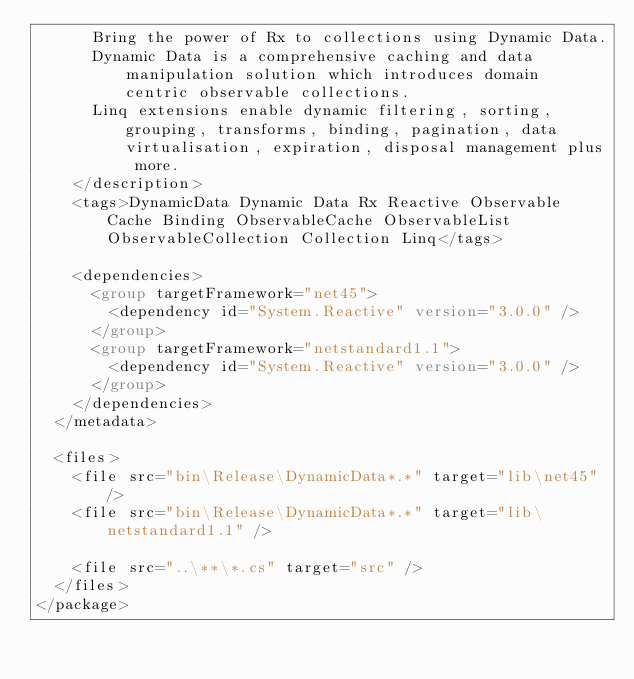<code> <loc_0><loc_0><loc_500><loc_500><_XML_>      Bring the power of Rx to collections using Dynamic Data.
      Dynamic Data is a comprehensive caching and data manipulation solution which introduces domain centric observable collections.
      Linq extensions enable dynamic filtering, sorting, grouping, transforms, binding, pagination, data virtualisation, expiration, disposal management plus more.
    </description>
    <tags>DynamicData Dynamic Data Rx Reactive Observable Cache Binding ObservableCache ObservableList ObservableCollection Collection Linq</tags>

    <dependencies>
      <group targetFramework="net45">
        <dependency id="System.Reactive" version="3.0.0" />
      </group>
      <group targetFramework="netstandard1.1">
        <dependency id="System.Reactive" version="3.0.0" />
      </group>
    </dependencies>
  </metadata>

  <files>
    <file src="bin\Release\DynamicData*.*" target="lib\net45" />
    <file src="bin\Release\DynamicData*.*" target="lib\netstandard1.1" />
    
    <file src="..\**\*.cs" target="src" />
  </files>
</package></code> 